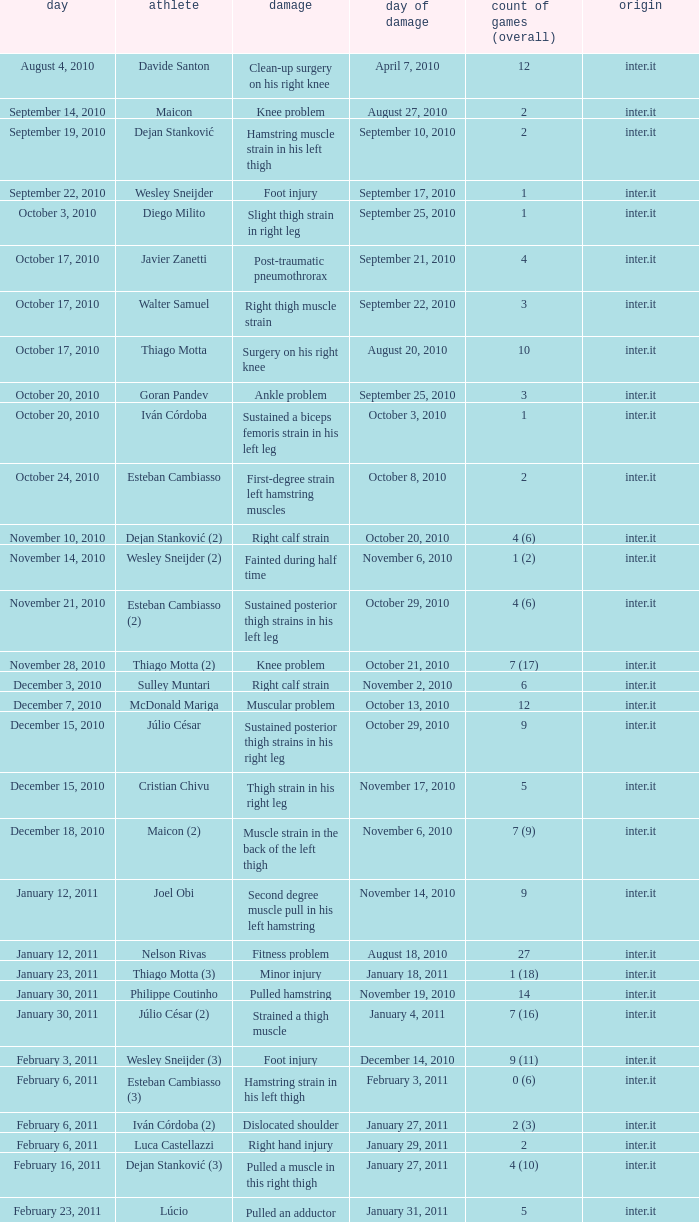What is the injury date for player wesley sneijder (2)? November 6, 2010. 